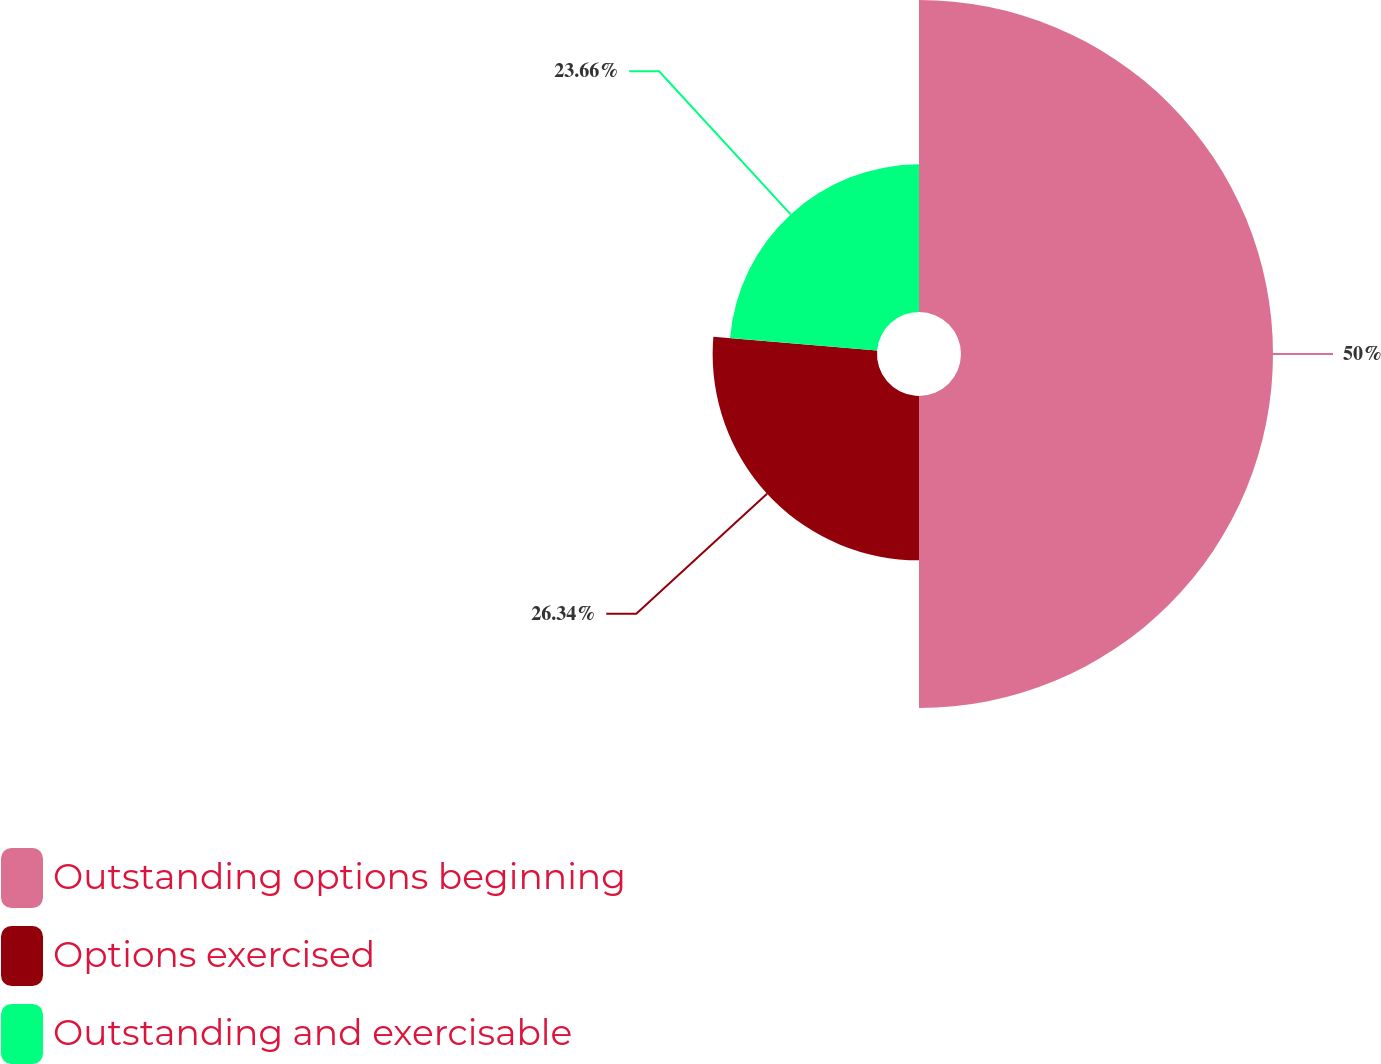<chart> <loc_0><loc_0><loc_500><loc_500><pie_chart><fcel>Outstanding options beginning<fcel>Options exercised<fcel>Outstanding and exercisable<nl><fcel>50.0%<fcel>26.34%<fcel>23.66%<nl></chart> 